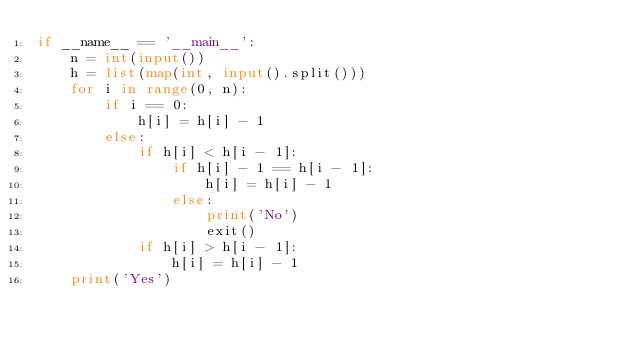<code> <loc_0><loc_0><loc_500><loc_500><_Python_>if __name__ == '__main__':
    n = int(input())
    h = list(map(int, input().split()))
    for i in range(0, n):
        if i == 0:
            h[i] = h[i] - 1
        else:
            if h[i] < h[i - 1]:
                if h[i] - 1 == h[i - 1]:
                    h[i] = h[i] - 1
                else:
                    print('No')
                    exit()
            if h[i] > h[i - 1]:
                h[i] = h[i] - 1
    print('Yes')
</code> 